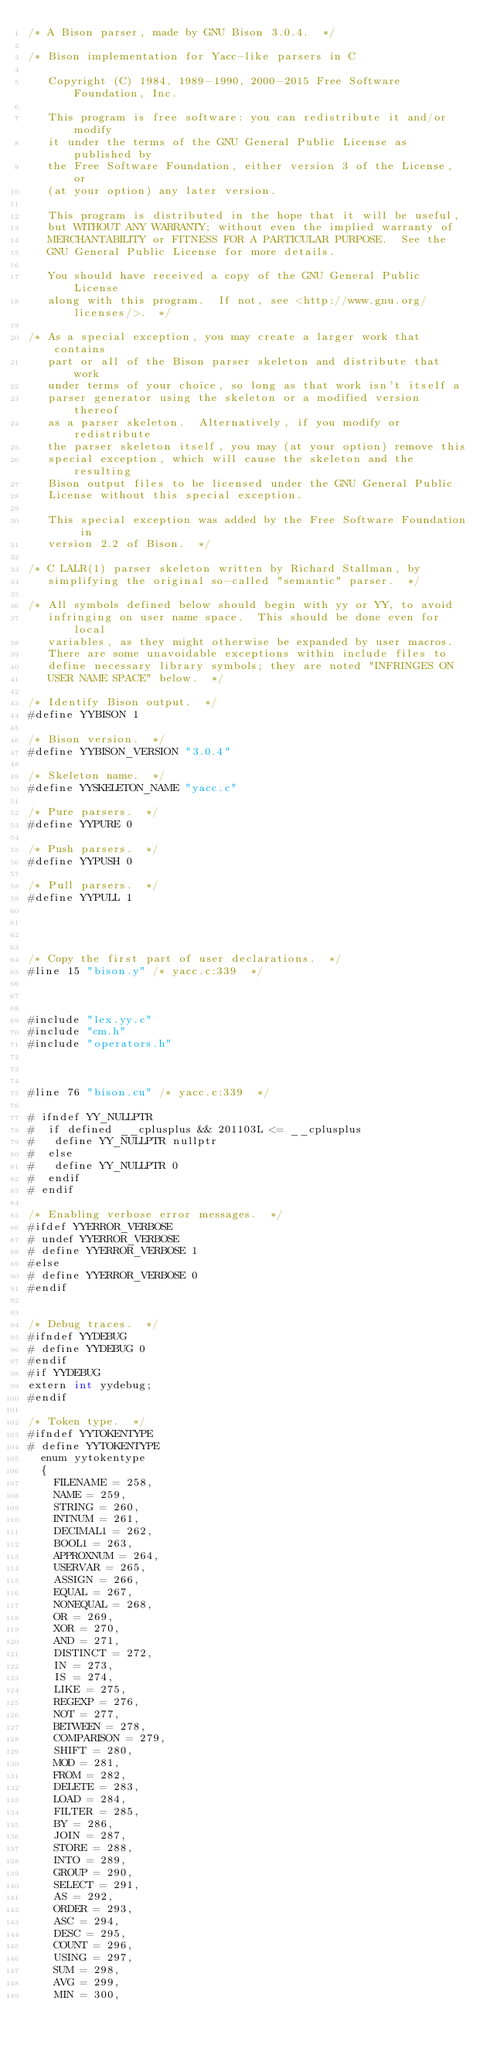<code> <loc_0><loc_0><loc_500><loc_500><_Cuda_>/* A Bison parser, made by GNU Bison 3.0.4.  */

/* Bison implementation for Yacc-like parsers in C

   Copyright (C) 1984, 1989-1990, 2000-2015 Free Software Foundation, Inc.

   This program is free software: you can redistribute it and/or modify
   it under the terms of the GNU General Public License as published by
   the Free Software Foundation, either version 3 of the License, or
   (at your option) any later version.

   This program is distributed in the hope that it will be useful,
   but WITHOUT ANY WARRANTY; without even the implied warranty of
   MERCHANTABILITY or FITNESS FOR A PARTICULAR PURPOSE.  See the
   GNU General Public License for more details.

   You should have received a copy of the GNU General Public License
   along with this program.  If not, see <http://www.gnu.org/licenses/>.  */

/* As a special exception, you may create a larger work that contains
   part or all of the Bison parser skeleton and distribute that work
   under terms of your choice, so long as that work isn't itself a
   parser generator using the skeleton or a modified version thereof
   as a parser skeleton.  Alternatively, if you modify or redistribute
   the parser skeleton itself, you may (at your option) remove this
   special exception, which will cause the skeleton and the resulting
   Bison output files to be licensed under the GNU General Public
   License without this special exception.

   This special exception was added by the Free Software Foundation in
   version 2.2 of Bison.  */

/* C LALR(1) parser skeleton written by Richard Stallman, by
   simplifying the original so-called "semantic" parser.  */

/* All symbols defined below should begin with yy or YY, to avoid
   infringing on user name space.  This should be done even for local
   variables, as they might otherwise be expanded by user macros.
   There are some unavoidable exceptions within include files to
   define necessary library symbols; they are noted "INFRINGES ON
   USER NAME SPACE" below.  */

/* Identify Bison output.  */
#define YYBISON 1

/* Bison version.  */
#define YYBISON_VERSION "3.0.4"

/* Skeleton name.  */
#define YYSKELETON_NAME "yacc.c"

/* Pure parsers.  */
#define YYPURE 0

/* Push parsers.  */
#define YYPUSH 0

/* Pull parsers.  */
#define YYPULL 1




/* Copy the first part of user declarations.  */
#line 15 "bison.y" /* yacc.c:339  */



#include "lex.yy.c"
#include "cm.h"
#include "operators.h"



#line 76 "bison.cu" /* yacc.c:339  */

# ifndef YY_NULLPTR
#  if defined __cplusplus && 201103L <= __cplusplus
#   define YY_NULLPTR nullptr
#  else
#   define YY_NULLPTR 0
#  endif
# endif

/* Enabling verbose error messages.  */
#ifdef YYERROR_VERBOSE
# undef YYERROR_VERBOSE
# define YYERROR_VERBOSE 1
#else
# define YYERROR_VERBOSE 0
#endif


/* Debug traces.  */
#ifndef YYDEBUG
# define YYDEBUG 0
#endif
#if YYDEBUG
extern int yydebug;
#endif

/* Token type.  */
#ifndef YYTOKENTYPE
# define YYTOKENTYPE
  enum yytokentype
  {
    FILENAME = 258,
    NAME = 259,
    STRING = 260,
    INTNUM = 261,
    DECIMAL1 = 262,
    BOOL1 = 263,
    APPROXNUM = 264,
    USERVAR = 265,
    ASSIGN = 266,
    EQUAL = 267,
    NONEQUAL = 268,
    OR = 269,
    XOR = 270,
    AND = 271,
    DISTINCT = 272,
    IN = 273,
    IS = 274,
    LIKE = 275,
    REGEXP = 276,
    NOT = 277,
    BETWEEN = 278,
    COMPARISON = 279,
    SHIFT = 280,
    MOD = 281,
    FROM = 282,
    DELETE = 283,
    LOAD = 284,
    FILTER = 285,
    BY = 286,
    JOIN = 287,
    STORE = 288,
    INTO = 289,
    GROUP = 290,
    SELECT = 291,
    AS = 292,
    ORDER = 293,
    ASC = 294,
    DESC = 295,
    COUNT = 296,
    USING = 297,
    SUM = 298,
    AVG = 299,
    MIN = 300,</code> 